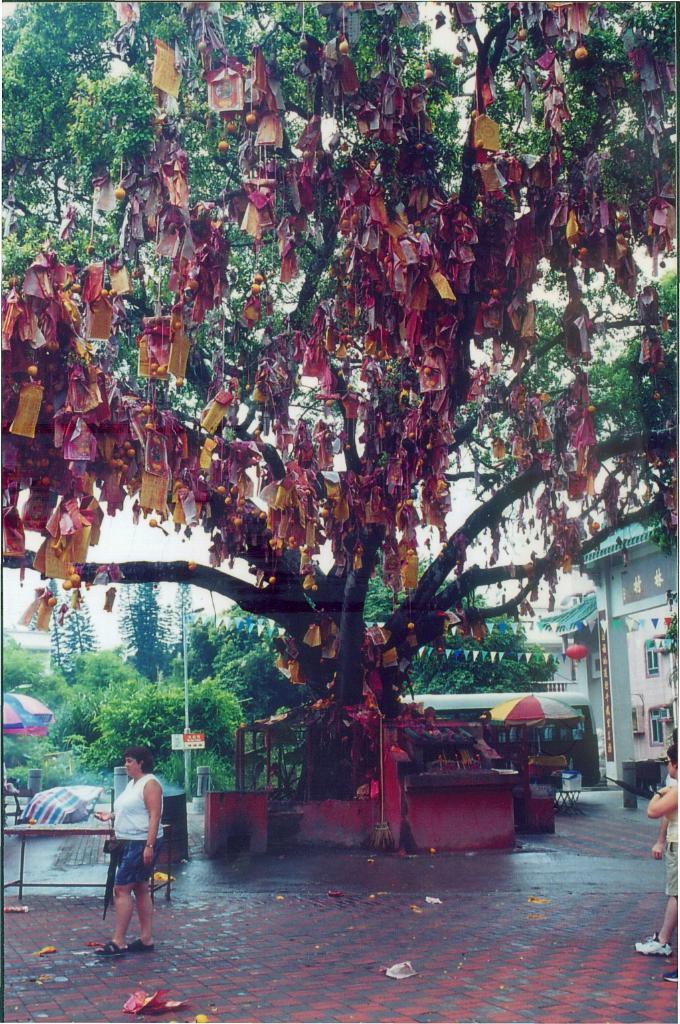Describe this image in one or two sentences. This image is taken outdoors. At the bottom of the image there is a floor. In the middle of the image there is a big tree and many papers are tied to it. In the background there are a few trees and plants and there is a building. There is an umbrella. On the right side of the image a kid is walking on the floor. On the left side of the image there is an umbrella, there is an empty table and a woman is walking on the floor. 